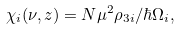Convert formula to latex. <formula><loc_0><loc_0><loc_500><loc_500>\chi _ { i } ( \nu , z ) = N \mu ^ { 2 } \rho _ { 3 i } / \hbar { \Omega } _ { i } ,</formula> 